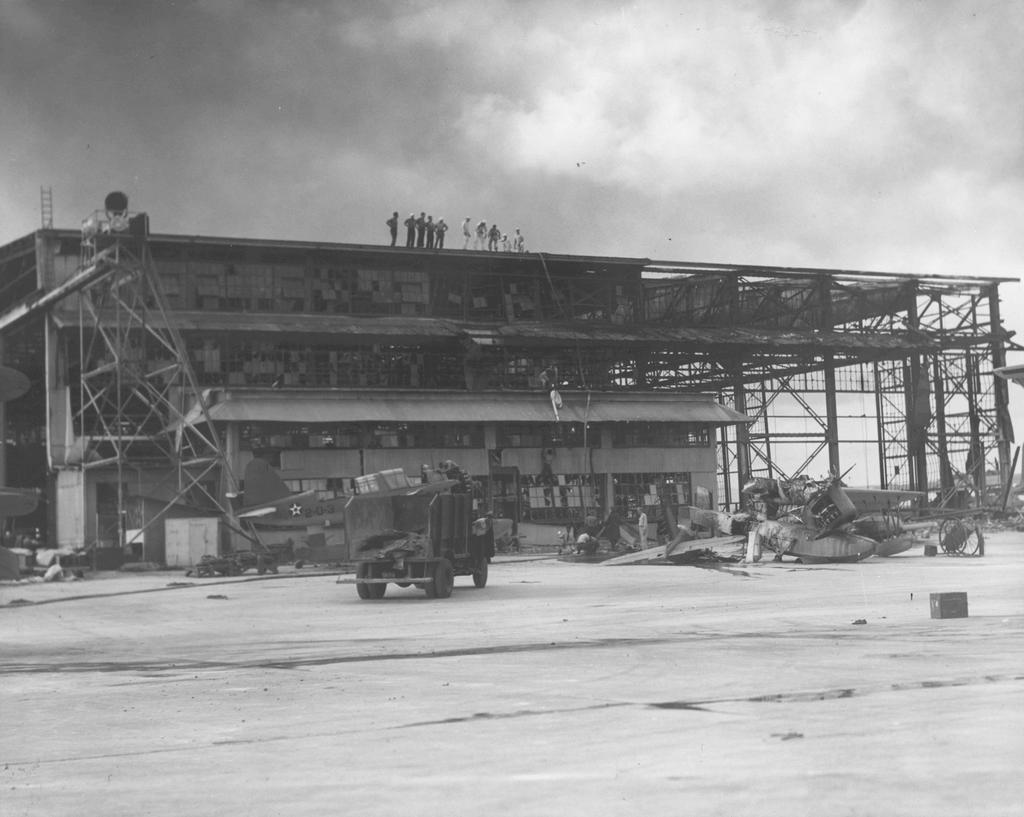Could you give a brief overview of what you see in this image? This picture describes about group of people, few people are standing on the building, in front of the building we can find few metal rods, vehicle and few more people. 